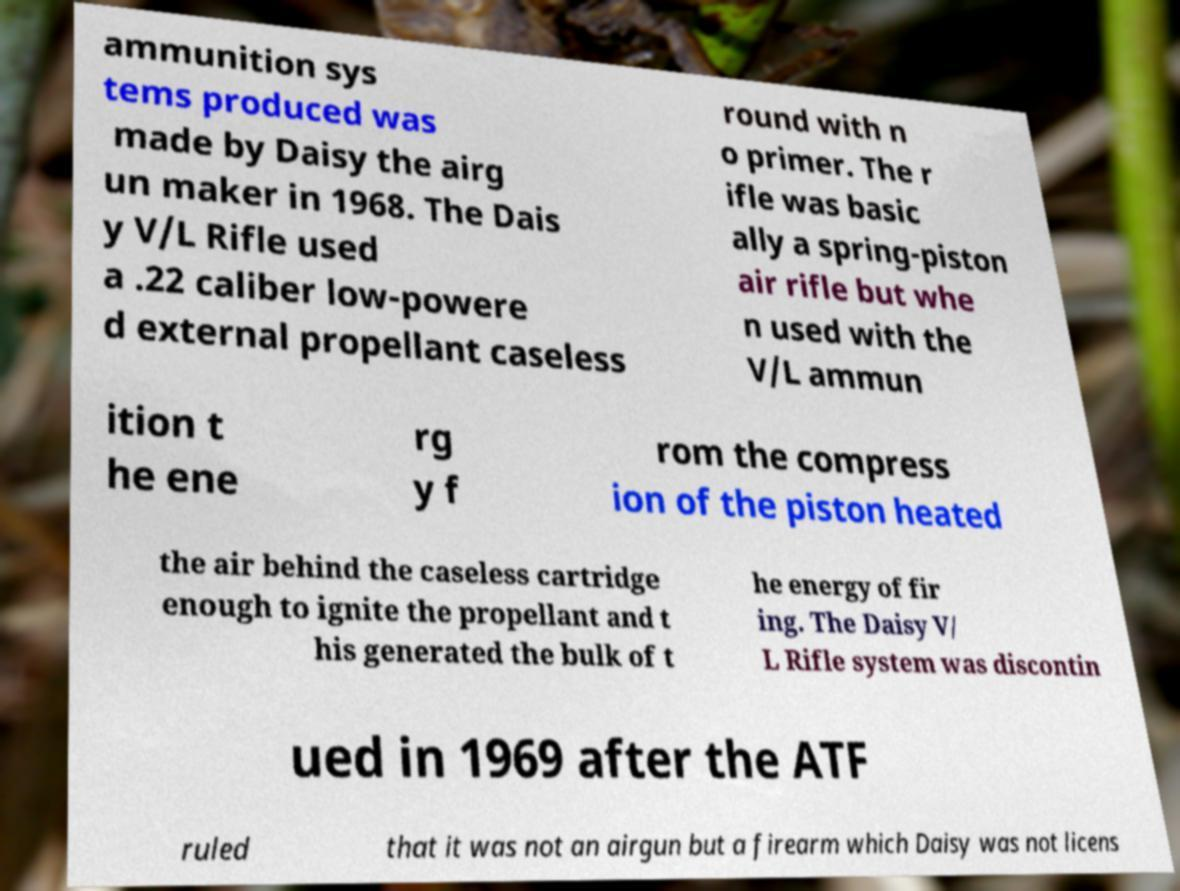Can you accurately transcribe the text from the provided image for me? ammunition sys tems produced was made by Daisy the airg un maker in 1968. The Dais y V/L Rifle used a .22 caliber low-powere d external propellant caseless round with n o primer. The r ifle was basic ally a spring-piston air rifle but whe n used with the V/L ammun ition t he ene rg y f rom the compress ion of the piston heated the air behind the caseless cartridge enough to ignite the propellant and t his generated the bulk of t he energy of fir ing. The Daisy V/ L Rifle system was discontin ued in 1969 after the ATF ruled that it was not an airgun but a firearm which Daisy was not licens 